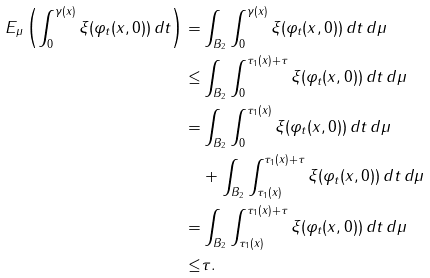<formula> <loc_0><loc_0><loc_500><loc_500>E _ { \mu } \left ( \int _ { 0 } ^ { \gamma ( x ) } \xi ( \varphi _ { t } ( x , 0 ) ) \, d t \right ) = & \int _ { B _ { 2 } } \int _ { 0 } ^ { \gamma ( x ) } \xi ( \varphi _ { t } ( x , 0 ) ) \, d t \, d \mu \\ \leq & \int _ { B _ { 2 } } \int _ { 0 } ^ { \tau _ { 1 } ( x ) + \tau } \xi ( \varphi _ { t } ( x , 0 ) ) \, d t \, d \mu \\ = & \int _ { B _ { 2 } } \int _ { 0 } ^ { \tau _ { 1 } ( x ) } \xi ( \varphi _ { t } ( x , 0 ) ) \, d t \, d \mu \\ & + \int _ { B _ { 2 } } \int _ { \tau _ { 1 } ( x ) } ^ { \tau _ { 1 } ( x ) + \tau } \xi ( \varphi _ { t } ( x , 0 ) ) \, d t \, d \mu \\ = & \int _ { B _ { 2 } } \int _ { \tau _ { 1 } ( x ) } ^ { \tau _ { 1 } ( x ) + \tau } \xi ( \varphi _ { t } ( x , 0 ) ) \, d t \, d \mu \\ \leq & \tau .</formula> 